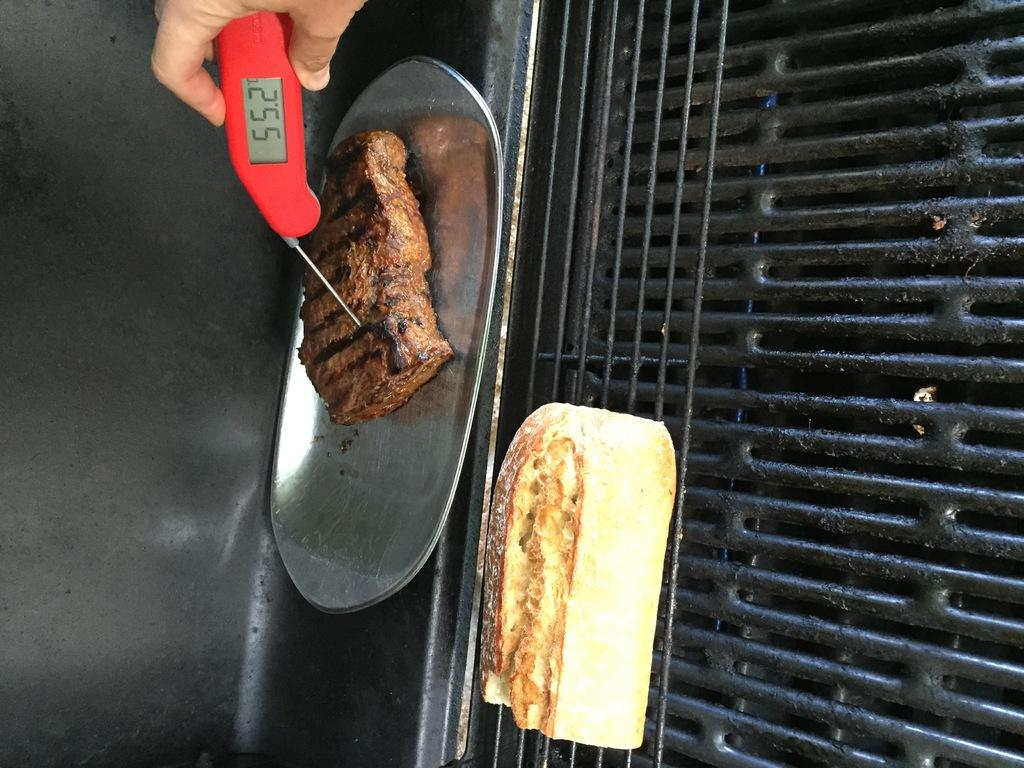Provide a one-sentence caption for the provided image. Checking the steak's internal temperature which is 55.2 degrees. 